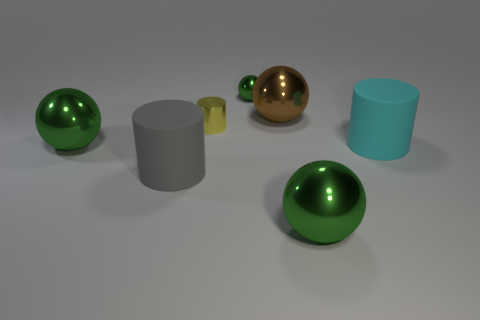How many green spheres must be subtracted to get 2 green spheres? 1 Subtract all big cylinders. How many cylinders are left? 1 Subtract all spheres. How many objects are left? 3 Subtract all brown spheres. How many spheres are left? 3 Add 2 large green matte cubes. How many objects exist? 9 Subtract 0 yellow cubes. How many objects are left? 7 Subtract 1 spheres. How many spheres are left? 3 Subtract all yellow spheres. Subtract all blue cubes. How many spheres are left? 4 Subtract all yellow cylinders. How many red balls are left? 0 Subtract all large gray matte objects. Subtract all large gray objects. How many objects are left? 5 